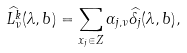<formula> <loc_0><loc_0><loc_500><loc_500>\widehat { L _ { \nu } ^ { k } } ( \lambda , b ) = \sum _ { x _ { j } \in Z } \alpha _ { j , \nu } \widehat { \delta _ { j } } ( \lambda , b ) ,</formula> 